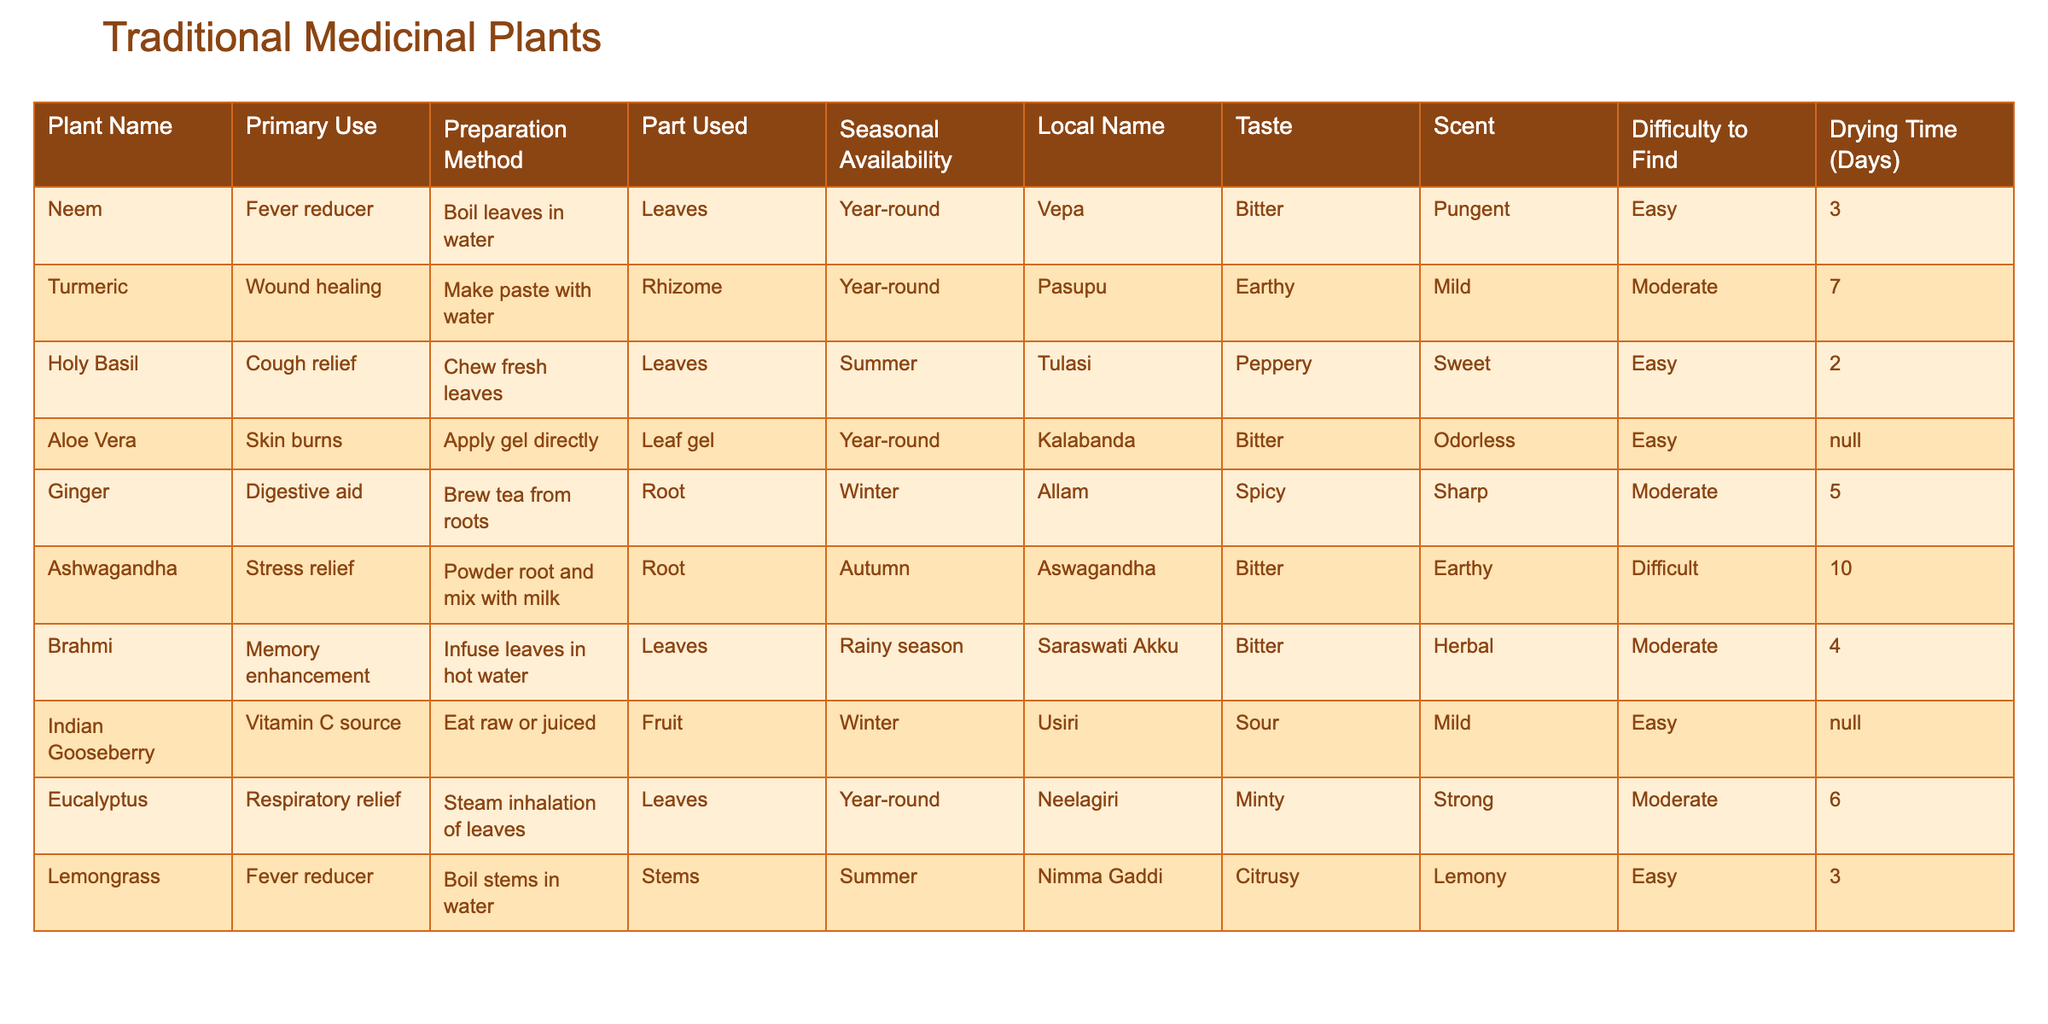What is the primary use of Neem? In the table, I can find the entry corresponding to Neem in the "Primary Use" column. It is listed as "Fever reducer."
Answer: Fever reducer Which plant is used for cough relief? By looking at the "Primary Use" column, I can see that Holy Basil is the plant associated with cough relief.
Answer: Holy Basil How many days does it take to dry Ashwagandha? I check the "Drying Time (Days)" column for Ashwagandha and see it is listed as 10 days.
Answer: 10 days Is Aloe Vera available year-round? I look at the "Seasonal Availability" column for Aloe Vera and see it's marked as "Year-round," which means it is available throughout the year.
Answer: Yes Which plant has a taste described as "Citrusy"? I can find the "Taste" column for all plants, and Lemongrass is the one described as having a "Citrusy" taste.
Answer: Lemongrass What is the average drying time for all the plants listed? I find the drying times for each plant and sum them up: 3 + 7 + 2 + 10 + 5 + 10 + 4 + 0 + 6 + 3 = 50 days. There are 9 entries (Aloe Vera is not applicable), so the average is 50/9 ≈ 5.56 days.
Answer: Approximately 5.56 days Which plant has the longest drying time? I review the "Drying Time (Days)" column and see that Ashwagandha has the longest drying time at 10 days.
Answer: Ashwagandha Are there any plants that can be used for skin burns? Looking at the "Primary Use" column, I find that Aloe Vera is specifically listed for skin burns.
Answer: Yes, Aloe Vera How many plants can help relieve fever? I check the "Primary Use" column and count the plants listed as fever reducers: Neem and Lemongrass. So there are 2 plants.
Answer: 2 plants What part of the plant is used for the preparation of Turmeric? I check the "Part Used" column for Turmeric and it indicates that the rhizome is used for its preparation.
Answer: Rhizome 